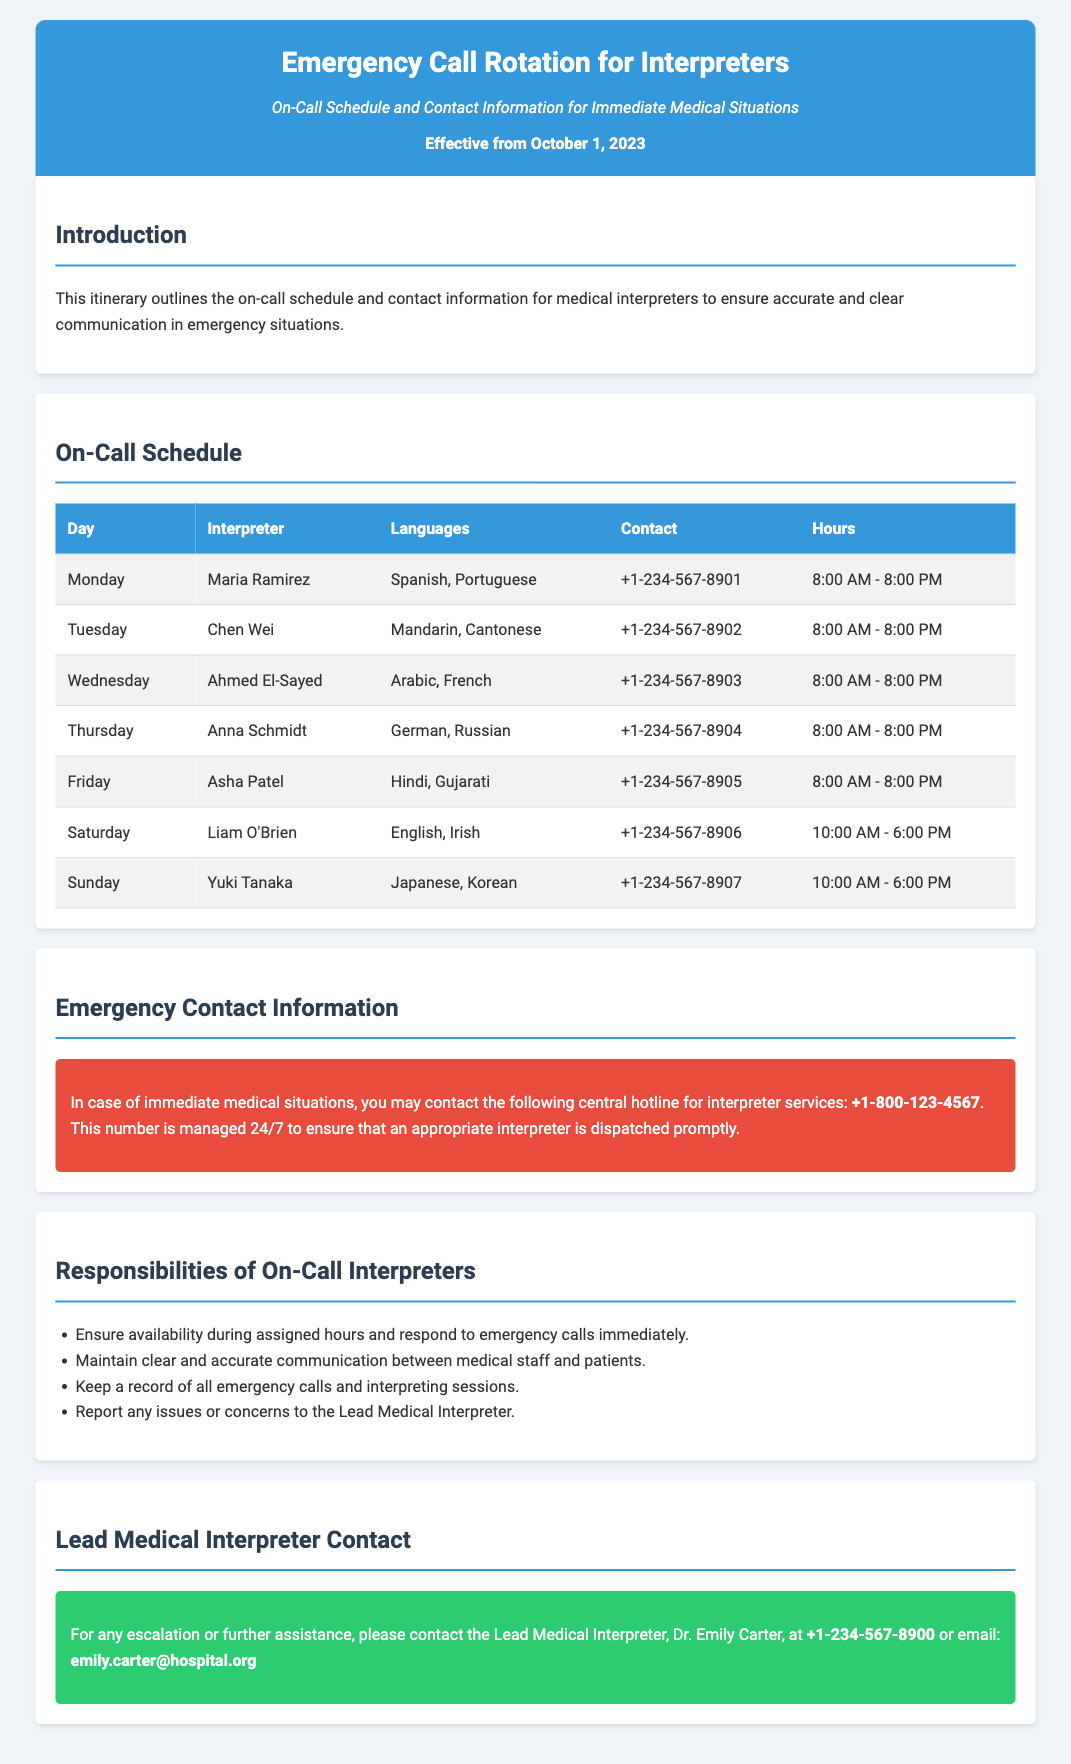What is the effective date of the itinerary? The effective date is stated at the top of the document.
Answer: October 1, 2023 Who is the interpreter on duty for Wednesday? The Wednesday interpreter's name is listed in the on-call schedule section of the document.
Answer: Ahmed El-Sayed What languages does Asha Patel interpret? The languages interpreted by Asha Patel are specified in the on-call schedule.
Answer: Hindi, Gujarati What is the contact number for the Lead Medical Interpreter? The contact number is provided in the Lead Medical Interpreter section.
Answer: +1-234-567-8900 How many hours is the daily on-call schedule for Monday interpreters? The hours are mentioned next to the interpreter’s name in the on-call schedule.
Answer: 12 hours What should on-call interpreters do if they encounter issues? The responsibilities section outlines what interpreters should do in this situation.
Answer: Report to the Lead Medical Interpreter What is the central hotline number for interpreter services? The emergency contact information provides this number.
Answer: +1-800-123-4567 Which day does Liam O'Brien interpret? Liam O'Brien's assigned day is found in the on-call schedule.
Answer: Saturday What is the translation responsibility of interpreters during shifts? This responsibility is mentioned under the section for Responsibilities of On-Call Interpreters.
Answer: Maintain clear and accurate communication 